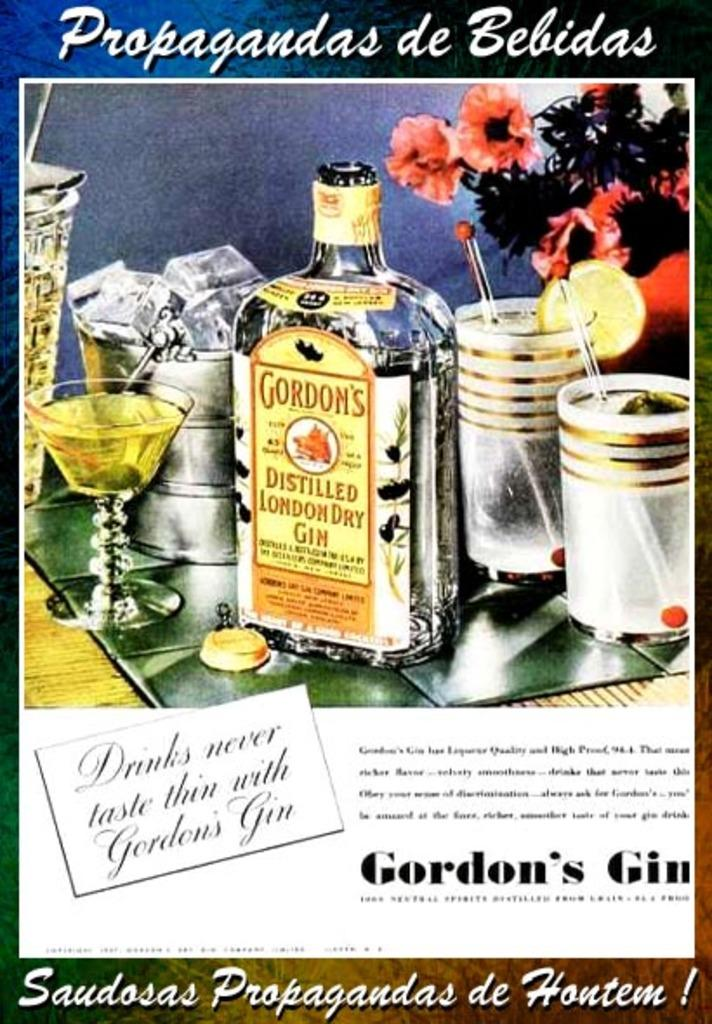What is depicted in the image? There is a picture of a bottle in the image. What else can be seen in the image besides the bottle? There are glasses and a flower in the image. What type of record is being played in the background of the image? There is no record or music player present in the image, so it is not possible to determine if a record is being played. 